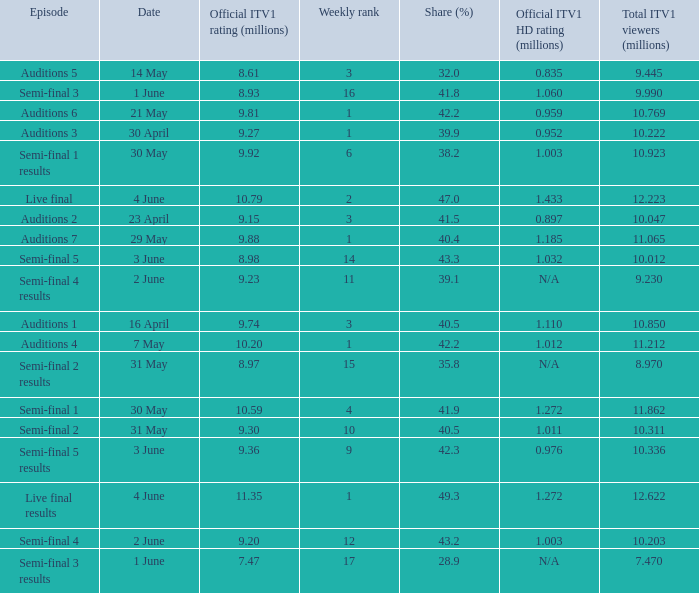What was the total ITV1 viewers in millions for the episode with a share (%) of 28.9?  7.47. 